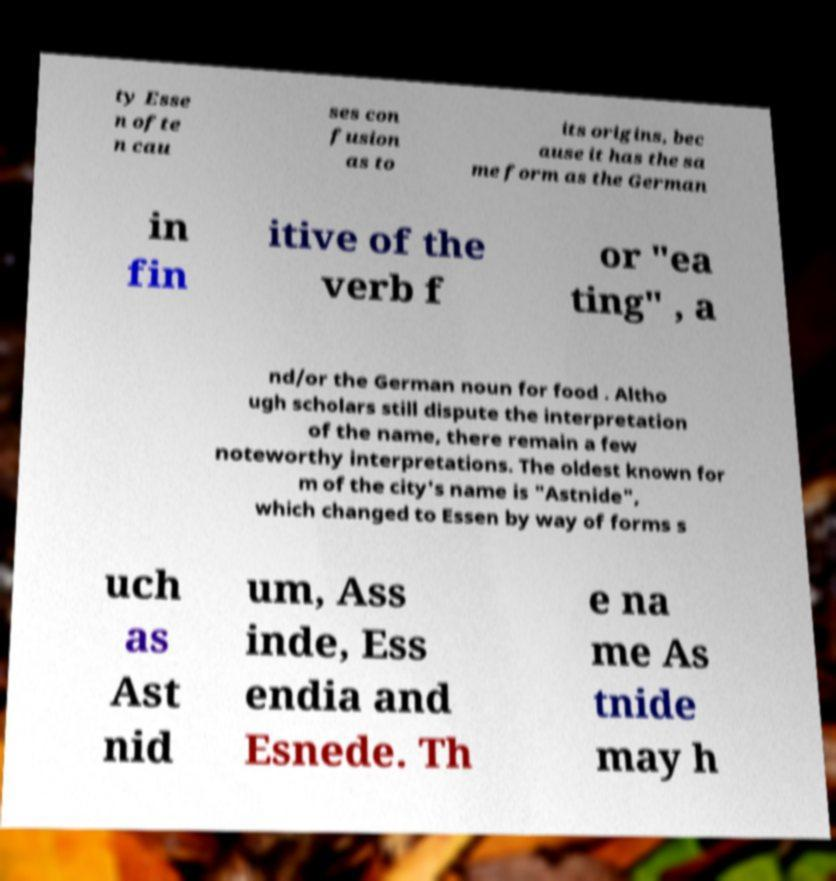Please read and relay the text visible in this image. What does it say? ty Esse n ofte n cau ses con fusion as to its origins, bec ause it has the sa me form as the German in fin itive of the verb f or "ea ting" , a nd/or the German noun for food . Altho ugh scholars still dispute the interpretation of the name, there remain a few noteworthy interpretations. The oldest known for m of the city's name is "Astnide", which changed to Essen by way of forms s uch as Ast nid um, Ass inde, Ess endia and Esnede. Th e na me As tnide may h 